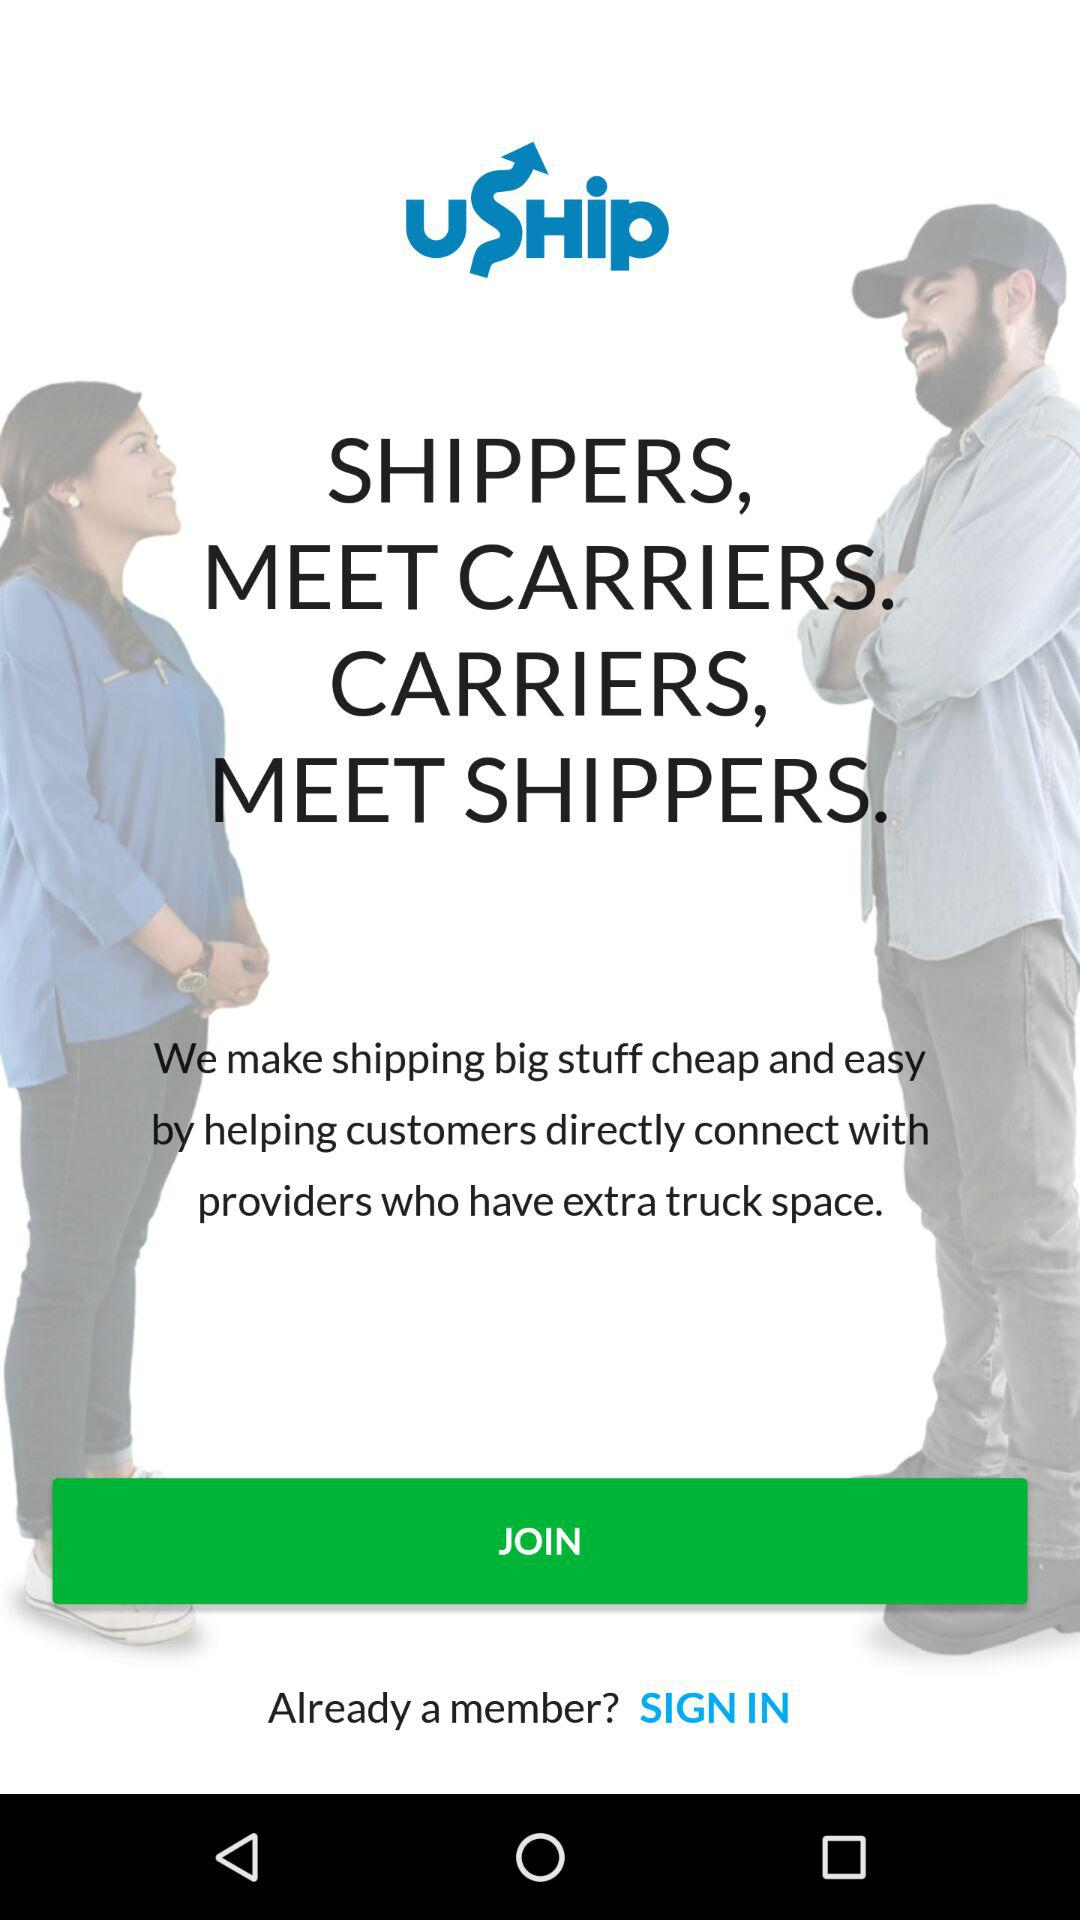How much does it cost to ship?
When the provided information is insufficient, respond with <no answer>. <no answer> 